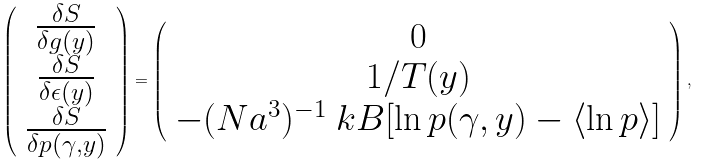Convert formula to latex. <formula><loc_0><loc_0><loc_500><loc_500>\left ( \begin{array} { c } \frac { \delta S } { \delta g ( y ) } \\ \frac { \delta S } { \delta \epsilon ( y ) } \\ \frac { \delta S } { \delta p ( \gamma , y ) } \end{array} \right ) = \left ( \begin{array} { c } 0 \\ 1 / T ( y ) \\ - ( N a ^ { 3 } ) ^ { - 1 } \ k B [ \ln p ( \gamma , y ) - \langle \ln p \rangle ] \end{array} \right ) ,</formula> 